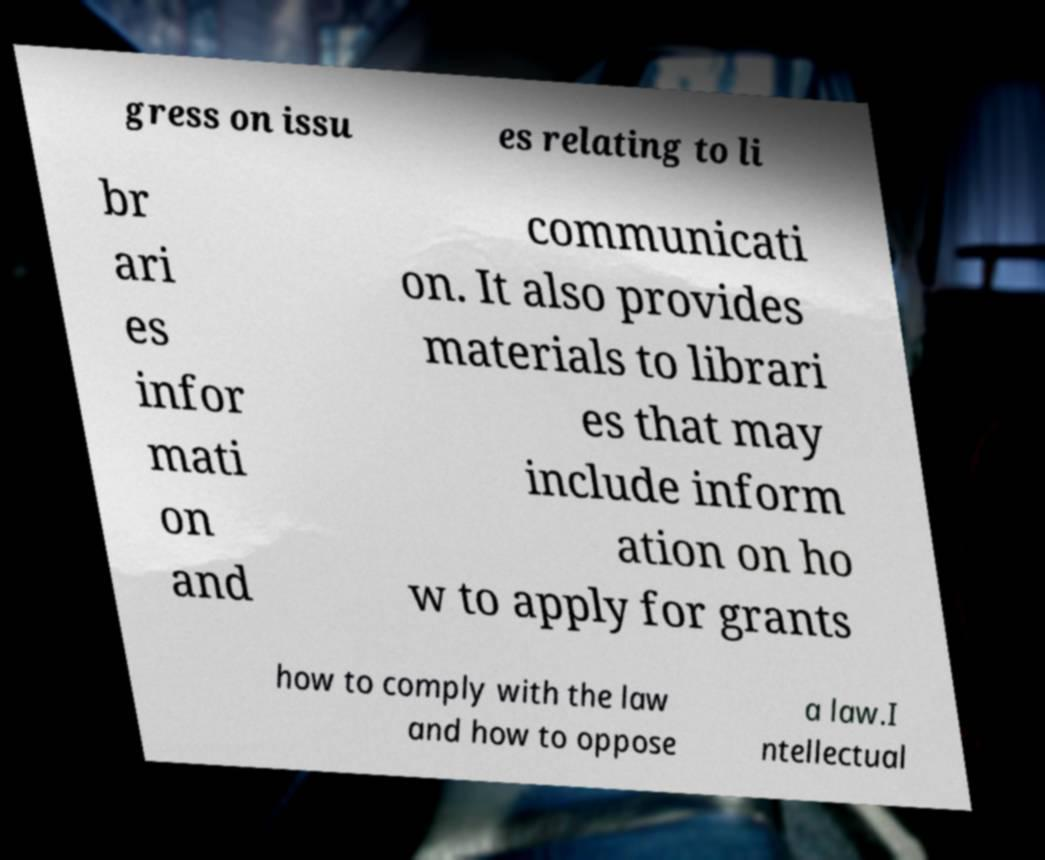Can you read and provide the text displayed in the image?This photo seems to have some interesting text. Can you extract and type it out for me? gress on issu es relating to li br ari es infor mati on and communicati on. It also provides materials to librari es that may include inform ation on ho w to apply for grants how to comply with the law and how to oppose a law.I ntellectual 